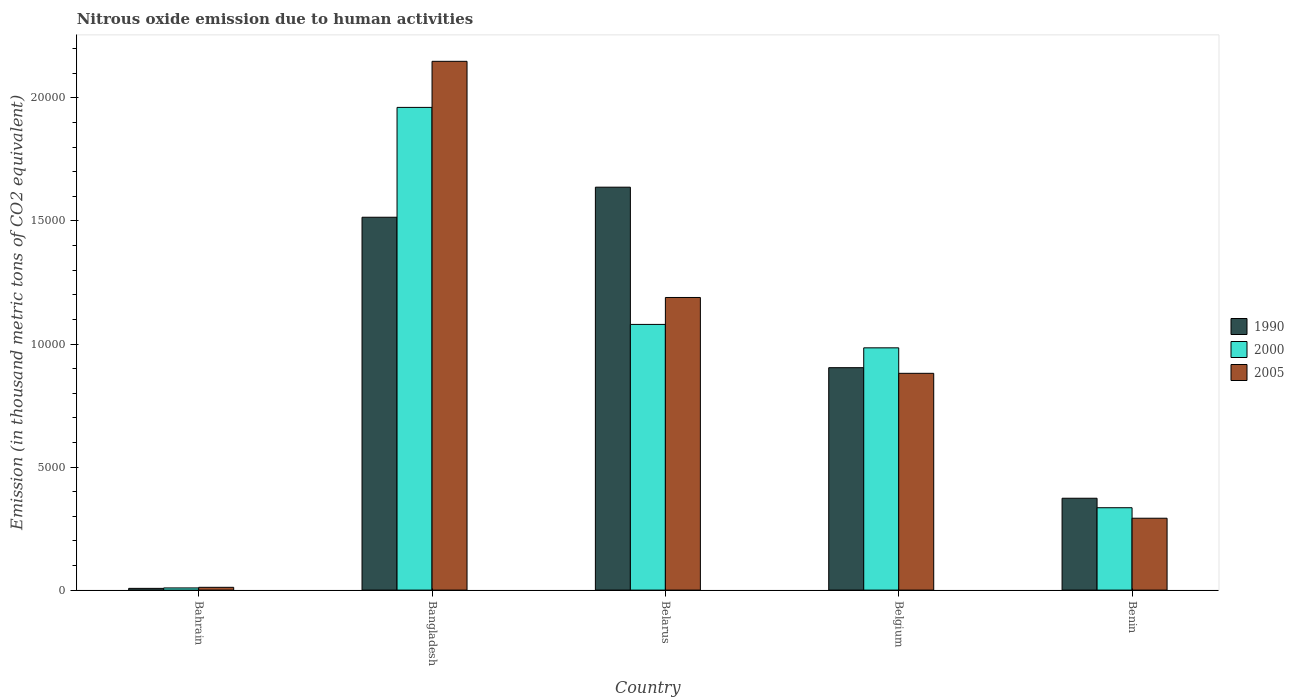How many different coloured bars are there?
Offer a very short reply. 3. Are the number of bars per tick equal to the number of legend labels?
Your response must be concise. Yes. Are the number of bars on each tick of the X-axis equal?
Your response must be concise. Yes. What is the label of the 1st group of bars from the left?
Provide a succinct answer. Bahrain. In how many cases, is the number of bars for a given country not equal to the number of legend labels?
Provide a succinct answer. 0. What is the amount of nitrous oxide emitted in 1990 in Belgium?
Your answer should be very brief. 9037.7. Across all countries, what is the maximum amount of nitrous oxide emitted in 1990?
Keep it short and to the point. 1.64e+04. Across all countries, what is the minimum amount of nitrous oxide emitted in 2005?
Make the answer very short. 112.9. In which country was the amount of nitrous oxide emitted in 1990 maximum?
Provide a succinct answer. Belarus. In which country was the amount of nitrous oxide emitted in 2005 minimum?
Offer a very short reply. Bahrain. What is the total amount of nitrous oxide emitted in 2005 in the graph?
Provide a succinct answer. 4.52e+04. What is the difference between the amount of nitrous oxide emitted in 2000 in Bangladesh and that in Belgium?
Offer a terse response. 9770.1. What is the difference between the amount of nitrous oxide emitted in 1990 in Bangladesh and the amount of nitrous oxide emitted in 2000 in Belarus?
Your answer should be very brief. 4354.7. What is the average amount of nitrous oxide emitted in 2000 per country?
Offer a terse response. 8737.92. What is the difference between the amount of nitrous oxide emitted of/in 1990 and amount of nitrous oxide emitted of/in 2005 in Benin?
Offer a terse response. 812.1. What is the ratio of the amount of nitrous oxide emitted in 2005 in Bangladesh to that in Belarus?
Make the answer very short. 1.81. Is the difference between the amount of nitrous oxide emitted in 1990 in Belgium and Benin greater than the difference between the amount of nitrous oxide emitted in 2005 in Belgium and Benin?
Your response must be concise. No. What is the difference between the highest and the second highest amount of nitrous oxide emitted in 1990?
Your answer should be compact. 7334.6. What is the difference between the highest and the lowest amount of nitrous oxide emitted in 2005?
Your answer should be very brief. 2.14e+04. In how many countries, is the amount of nitrous oxide emitted in 1990 greater than the average amount of nitrous oxide emitted in 1990 taken over all countries?
Your answer should be compact. 3. Is the sum of the amount of nitrous oxide emitted in 2005 in Bahrain and Belarus greater than the maximum amount of nitrous oxide emitted in 1990 across all countries?
Provide a short and direct response. No. What does the 1st bar from the left in Bangladesh represents?
Provide a succinct answer. 1990. What does the 1st bar from the right in Belgium represents?
Give a very brief answer. 2005. Is it the case that in every country, the sum of the amount of nitrous oxide emitted in 2000 and amount of nitrous oxide emitted in 2005 is greater than the amount of nitrous oxide emitted in 1990?
Offer a terse response. Yes. How many bars are there?
Offer a terse response. 15. How many countries are there in the graph?
Make the answer very short. 5. What is the difference between two consecutive major ticks on the Y-axis?
Give a very brief answer. 5000. Are the values on the major ticks of Y-axis written in scientific E-notation?
Offer a very short reply. No. Where does the legend appear in the graph?
Your answer should be compact. Center right. What is the title of the graph?
Make the answer very short. Nitrous oxide emission due to human activities. Does "2005" appear as one of the legend labels in the graph?
Your answer should be compact. Yes. What is the label or title of the X-axis?
Your response must be concise. Country. What is the label or title of the Y-axis?
Offer a very short reply. Emission (in thousand metric tons of CO2 equivalent). What is the Emission (in thousand metric tons of CO2 equivalent) of 1990 in Bahrain?
Your answer should be very brief. 70.2. What is the Emission (in thousand metric tons of CO2 equivalent) of 2000 in Bahrain?
Offer a terse response. 88.2. What is the Emission (in thousand metric tons of CO2 equivalent) of 2005 in Bahrain?
Provide a short and direct response. 112.9. What is the Emission (in thousand metric tons of CO2 equivalent) in 1990 in Bangladesh?
Provide a short and direct response. 1.52e+04. What is the Emission (in thousand metric tons of CO2 equivalent) of 2000 in Bangladesh?
Keep it short and to the point. 1.96e+04. What is the Emission (in thousand metric tons of CO2 equivalent) in 2005 in Bangladesh?
Make the answer very short. 2.15e+04. What is the Emission (in thousand metric tons of CO2 equivalent) of 1990 in Belarus?
Make the answer very short. 1.64e+04. What is the Emission (in thousand metric tons of CO2 equivalent) in 2000 in Belarus?
Offer a very short reply. 1.08e+04. What is the Emission (in thousand metric tons of CO2 equivalent) of 2005 in Belarus?
Your answer should be very brief. 1.19e+04. What is the Emission (in thousand metric tons of CO2 equivalent) of 1990 in Belgium?
Provide a succinct answer. 9037.7. What is the Emission (in thousand metric tons of CO2 equivalent) of 2000 in Belgium?
Ensure brevity in your answer.  9844.1. What is the Emission (in thousand metric tons of CO2 equivalent) in 2005 in Belgium?
Give a very brief answer. 8808.6. What is the Emission (in thousand metric tons of CO2 equivalent) of 1990 in Benin?
Provide a short and direct response. 3732.5. What is the Emission (in thousand metric tons of CO2 equivalent) of 2000 in Benin?
Offer a very short reply. 3347.2. What is the Emission (in thousand metric tons of CO2 equivalent) of 2005 in Benin?
Give a very brief answer. 2920.4. Across all countries, what is the maximum Emission (in thousand metric tons of CO2 equivalent) of 1990?
Ensure brevity in your answer.  1.64e+04. Across all countries, what is the maximum Emission (in thousand metric tons of CO2 equivalent) of 2000?
Your response must be concise. 1.96e+04. Across all countries, what is the maximum Emission (in thousand metric tons of CO2 equivalent) of 2005?
Offer a very short reply. 2.15e+04. Across all countries, what is the minimum Emission (in thousand metric tons of CO2 equivalent) in 1990?
Your response must be concise. 70.2. Across all countries, what is the minimum Emission (in thousand metric tons of CO2 equivalent) of 2000?
Ensure brevity in your answer.  88.2. Across all countries, what is the minimum Emission (in thousand metric tons of CO2 equivalent) in 2005?
Your answer should be very brief. 112.9. What is the total Emission (in thousand metric tons of CO2 equivalent) in 1990 in the graph?
Ensure brevity in your answer.  4.44e+04. What is the total Emission (in thousand metric tons of CO2 equivalent) of 2000 in the graph?
Offer a very short reply. 4.37e+04. What is the total Emission (in thousand metric tons of CO2 equivalent) in 2005 in the graph?
Your response must be concise. 4.52e+04. What is the difference between the Emission (in thousand metric tons of CO2 equivalent) of 1990 in Bahrain and that in Bangladesh?
Offer a very short reply. -1.51e+04. What is the difference between the Emission (in thousand metric tons of CO2 equivalent) in 2000 in Bahrain and that in Bangladesh?
Your response must be concise. -1.95e+04. What is the difference between the Emission (in thousand metric tons of CO2 equivalent) of 2005 in Bahrain and that in Bangladesh?
Offer a terse response. -2.14e+04. What is the difference between the Emission (in thousand metric tons of CO2 equivalent) of 1990 in Bahrain and that in Belarus?
Provide a short and direct response. -1.63e+04. What is the difference between the Emission (in thousand metric tons of CO2 equivalent) of 2000 in Bahrain and that in Belarus?
Make the answer very short. -1.07e+04. What is the difference between the Emission (in thousand metric tons of CO2 equivalent) in 2005 in Bahrain and that in Belarus?
Ensure brevity in your answer.  -1.18e+04. What is the difference between the Emission (in thousand metric tons of CO2 equivalent) of 1990 in Bahrain and that in Belgium?
Offer a terse response. -8967.5. What is the difference between the Emission (in thousand metric tons of CO2 equivalent) in 2000 in Bahrain and that in Belgium?
Your answer should be compact. -9755.9. What is the difference between the Emission (in thousand metric tons of CO2 equivalent) of 2005 in Bahrain and that in Belgium?
Make the answer very short. -8695.7. What is the difference between the Emission (in thousand metric tons of CO2 equivalent) of 1990 in Bahrain and that in Benin?
Offer a terse response. -3662.3. What is the difference between the Emission (in thousand metric tons of CO2 equivalent) of 2000 in Bahrain and that in Benin?
Keep it short and to the point. -3259. What is the difference between the Emission (in thousand metric tons of CO2 equivalent) in 2005 in Bahrain and that in Benin?
Make the answer very short. -2807.5. What is the difference between the Emission (in thousand metric tons of CO2 equivalent) in 1990 in Bangladesh and that in Belarus?
Offer a terse response. -1221.7. What is the difference between the Emission (in thousand metric tons of CO2 equivalent) in 2000 in Bangladesh and that in Belarus?
Your answer should be compact. 8818.3. What is the difference between the Emission (in thousand metric tons of CO2 equivalent) in 2005 in Bangladesh and that in Belarus?
Provide a short and direct response. 9596.5. What is the difference between the Emission (in thousand metric tons of CO2 equivalent) of 1990 in Bangladesh and that in Belgium?
Offer a terse response. 6112.9. What is the difference between the Emission (in thousand metric tons of CO2 equivalent) of 2000 in Bangladesh and that in Belgium?
Make the answer very short. 9770.1. What is the difference between the Emission (in thousand metric tons of CO2 equivalent) of 2005 in Bangladesh and that in Belgium?
Provide a short and direct response. 1.27e+04. What is the difference between the Emission (in thousand metric tons of CO2 equivalent) of 1990 in Bangladesh and that in Benin?
Provide a succinct answer. 1.14e+04. What is the difference between the Emission (in thousand metric tons of CO2 equivalent) in 2000 in Bangladesh and that in Benin?
Your response must be concise. 1.63e+04. What is the difference between the Emission (in thousand metric tons of CO2 equivalent) of 2005 in Bangladesh and that in Benin?
Keep it short and to the point. 1.86e+04. What is the difference between the Emission (in thousand metric tons of CO2 equivalent) in 1990 in Belarus and that in Belgium?
Keep it short and to the point. 7334.6. What is the difference between the Emission (in thousand metric tons of CO2 equivalent) of 2000 in Belarus and that in Belgium?
Your answer should be compact. 951.8. What is the difference between the Emission (in thousand metric tons of CO2 equivalent) of 2005 in Belarus and that in Belgium?
Offer a very short reply. 3081.6. What is the difference between the Emission (in thousand metric tons of CO2 equivalent) in 1990 in Belarus and that in Benin?
Keep it short and to the point. 1.26e+04. What is the difference between the Emission (in thousand metric tons of CO2 equivalent) in 2000 in Belarus and that in Benin?
Provide a succinct answer. 7448.7. What is the difference between the Emission (in thousand metric tons of CO2 equivalent) of 2005 in Belarus and that in Benin?
Give a very brief answer. 8969.8. What is the difference between the Emission (in thousand metric tons of CO2 equivalent) in 1990 in Belgium and that in Benin?
Keep it short and to the point. 5305.2. What is the difference between the Emission (in thousand metric tons of CO2 equivalent) of 2000 in Belgium and that in Benin?
Provide a succinct answer. 6496.9. What is the difference between the Emission (in thousand metric tons of CO2 equivalent) of 2005 in Belgium and that in Benin?
Provide a short and direct response. 5888.2. What is the difference between the Emission (in thousand metric tons of CO2 equivalent) in 1990 in Bahrain and the Emission (in thousand metric tons of CO2 equivalent) in 2000 in Bangladesh?
Keep it short and to the point. -1.95e+04. What is the difference between the Emission (in thousand metric tons of CO2 equivalent) in 1990 in Bahrain and the Emission (in thousand metric tons of CO2 equivalent) in 2005 in Bangladesh?
Offer a terse response. -2.14e+04. What is the difference between the Emission (in thousand metric tons of CO2 equivalent) in 2000 in Bahrain and the Emission (in thousand metric tons of CO2 equivalent) in 2005 in Bangladesh?
Your response must be concise. -2.14e+04. What is the difference between the Emission (in thousand metric tons of CO2 equivalent) in 1990 in Bahrain and the Emission (in thousand metric tons of CO2 equivalent) in 2000 in Belarus?
Your answer should be very brief. -1.07e+04. What is the difference between the Emission (in thousand metric tons of CO2 equivalent) of 1990 in Bahrain and the Emission (in thousand metric tons of CO2 equivalent) of 2005 in Belarus?
Offer a very short reply. -1.18e+04. What is the difference between the Emission (in thousand metric tons of CO2 equivalent) in 2000 in Bahrain and the Emission (in thousand metric tons of CO2 equivalent) in 2005 in Belarus?
Your response must be concise. -1.18e+04. What is the difference between the Emission (in thousand metric tons of CO2 equivalent) in 1990 in Bahrain and the Emission (in thousand metric tons of CO2 equivalent) in 2000 in Belgium?
Your answer should be very brief. -9773.9. What is the difference between the Emission (in thousand metric tons of CO2 equivalent) of 1990 in Bahrain and the Emission (in thousand metric tons of CO2 equivalent) of 2005 in Belgium?
Your answer should be very brief. -8738.4. What is the difference between the Emission (in thousand metric tons of CO2 equivalent) of 2000 in Bahrain and the Emission (in thousand metric tons of CO2 equivalent) of 2005 in Belgium?
Make the answer very short. -8720.4. What is the difference between the Emission (in thousand metric tons of CO2 equivalent) of 1990 in Bahrain and the Emission (in thousand metric tons of CO2 equivalent) of 2000 in Benin?
Your answer should be very brief. -3277. What is the difference between the Emission (in thousand metric tons of CO2 equivalent) in 1990 in Bahrain and the Emission (in thousand metric tons of CO2 equivalent) in 2005 in Benin?
Provide a short and direct response. -2850.2. What is the difference between the Emission (in thousand metric tons of CO2 equivalent) of 2000 in Bahrain and the Emission (in thousand metric tons of CO2 equivalent) of 2005 in Benin?
Provide a succinct answer. -2832.2. What is the difference between the Emission (in thousand metric tons of CO2 equivalent) in 1990 in Bangladesh and the Emission (in thousand metric tons of CO2 equivalent) in 2000 in Belarus?
Provide a succinct answer. 4354.7. What is the difference between the Emission (in thousand metric tons of CO2 equivalent) of 1990 in Bangladesh and the Emission (in thousand metric tons of CO2 equivalent) of 2005 in Belarus?
Offer a very short reply. 3260.4. What is the difference between the Emission (in thousand metric tons of CO2 equivalent) in 2000 in Bangladesh and the Emission (in thousand metric tons of CO2 equivalent) in 2005 in Belarus?
Ensure brevity in your answer.  7724. What is the difference between the Emission (in thousand metric tons of CO2 equivalent) in 1990 in Bangladesh and the Emission (in thousand metric tons of CO2 equivalent) in 2000 in Belgium?
Provide a short and direct response. 5306.5. What is the difference between the Emission (in thousand metric tons of CO2 equivalent) in 1990 in Bangladesh and the Emission (in thousand metric tons of CO2 equivalent) in 2005 in Belgium?
Keep it short and to the point. 6342. What is the difference between the Emission (in thousand metric tons of CO2 equivalent) in 2000 in Bangladesh and the Emission (in thousand metric tons of CO2 equivalent) in 2005 in Belgium?
Ensure brevity in your answer.  1.08e+04. What is the difference between the Emission (in thousand metric tons of CO2 equivalent) of 1990 in Bangladesh and the Emission (in thousand metric tons of CO2 equivalent) of 2000 in Benin?
Provide a short and direct response. 1.18e+04. What is the difference between the Emission (in thousand metric tons of CO2 equivalent) of 1990 in Bangladesh and the Emission (in thousand metric tons of CO2 equivalent) of 2005 in Benin?
Make the answer very short. 1.22e+04. What is the difference between the Emission (in thousand metric tons of CO2 equivalent) in 2000 in Bangladesh and the Emission (in thousand metric tons of CO2 equivalent) in 2005 in Benin?
Your response must be concise. 1.67e+04. What is the difference between the Emission (in thousand metric tons of CO2 equivalent) of 1990 in Belarus and the Emission (in thousand metric tons of CO2 equivalent) of 2000 in Belgium?
Provide a short and direct response. 6528.2. What is the difference between the Emission (in thousand metric tons of CO2 equivalent) of 1990 in Belarus and the Emission (in thousand metric tons of CO2 equivalent) of 2005 in Belgium?
Keep it short and to the point. 7563.7. What is the difference between the Emission (in thousand metric tons of CO2 equivalent) of 2000 in Belarus and the Emission (in thousand metric tons of CO2 equivalent) of 2005 in Belgium?
Give a very brief answer. 1987.3. What is the difference between the Emission (in thousand metric tons of CO2 equivalent) of 1990 in Belarus and the Emission (in thousand metric tons of CO2 equivalent) of 2000 in Benin?
Your answer should be very brief. 1.30e+04. What is the difference between the Emission (in thousand metric tons of CO2 equivalent) in 1990 in Belarus and the Emission (in thousand metric tons of CO2 equivalent) in 2005 in Benin?
Your answer should be compact. 1.35e+04. What is the difference between the Emission (in thousand metric tons of CO2 equivalent) in 2000 in Belarus and the Emission (in thousand metric tons of CO2 equivalent) in 2005 in Benin?
Make the answer very short. 7875.5. What is the difference between the Emission (in thousand metric tons of CO2 equivalent) of 1990 in Belgium and the Emission (in thousand metric tons of CO2 equivalent) of 2000 in Benin?
Keep it short and to the point. 5690.5. What is the difference between the Emission (in thousand metric tons of CO2 equivalent) of 1990 in Belgium and the Emission (in thousand metric tons of CO2 equivalent) of 2005 in Benin?
Offer a very short reply. 6117.3. What is the difference between the Emission (in thousand metric tons of CO2 equivalent) of 2000 in Belgium and the Emission (in thousand metric tons of CO2 equivalent) of 2005 in Benin?
Your response must be concise. 6923.7. What is the average Emission (in thousand metric tons of CO2 equivalent) of 1990 per country?
Offer a terse response. 8872.66. What is the average Emission (in thousand metric tons of CO2 equivalent) in 2000 per country?
Give a very brief answer. 8737.92. What is the average Emission (in thousand metric tons of CO2 equivalent) in 2005 per country?
Ensure brevity in your answer.  9043.76. What is the difference between the Emission (in thousand metric tons of CO2 equivalent) in 1990 and Emission (in thousand metric tons of CO2 equivalent) in 2005 in Bahrain?
Keep it short and to the point. -42.7. What is the difference between the Emission (in thousand metric tons of CO2 equivalent) in 2000 and Emission (in thousand metric tons of CO2 equivalent) in 2005 in Bahrain?
Make the answer very short. -24.7. What is the difference between the Emission (in thousand metric tons of CO2 equivalent) in 1990 and Emission (in thousand metric tons of CO2 equivalent) in 2000 in Bangladesh?
Provide a short and direct response. -4463.6. What is the difference between the Emission (in thousand metric tons of CO2 equivalent) of 1990 and Emission (in thousand metric tons of CO2 equivalent) of 2005 in Bangladesh?
Keep it short and to the point. -6336.1. What is the difference between the Emission (in thousand metric tons of CO2 equivalent) in 2000 and Emission (in thousand metric tons of CO2 equivalent) in 2005 in Bangladesh?
Offer a very short reply. -1872.5. What is the difference between the Emission (in thousand metric tons of CO2 equivalent) in 1990 and Emission (in thousand metric tons of CO2 equivalent) in 2000 in Belarus?
Your answer should be compact. 5576.4. What is the difference between the Emission (in thousand metric tons of CO2 equivalent) of 1990 and Emission (in thousand metric tons of CO2 equivalent) of 2005 in Belarus?
Provide a succinct answer. 4482.1. What is the difference between the Emission (in thousand metric tons of CO2 equivalent) of 2000 and Emission (in thousand metric tons of CO2 equivalent) of 2005 in Belarus?
Offer a very short reply. -1094.3. What is the difference between the Emission (in thousand metric tons of CO2 equivalent) in 1990 and Emission (in thousand metric tons of CO2 equivalent) in 2000 in Belgium?
Your answer should be compact. -806.4. What is the difference between the Emission (in thousand metric tons of CO2 equivalent) in 1990 and Emission (in thousand metric tons of CO2 equivalent) in 2005 in Belgium?
Provide a succinct answer. 229.1. What is the difference between the Emission (in thousand metric tons of CO2 equivalent) of 2000 and Emission (in thousand metric tons of CO2 equivalent) of 2005 in Belgium?
Your answer should be compact. 1035.5. What is the difference between the Emission (in thousand metric tons of CO2 equivalent) in 1990 and Emission (in thousand metric tons of CO2 equivalent) in 2000 in Benin?
Make the answer very short. 385.3. What is the difference between the Emission (in thousand metric tons of CO2 equivalent) of 1990 and Emission (in thousand metric tons of CO2 equivalent) of 2005 in Benin?
Ensure brevity in your answer.  812.1. What is the difference between the Emission (in thousand metric tons of CO2 equivalent) of 2000 and Emission (in thousand metric tons of CO2 equivalent) of 2005 in Benin?
Your answer should be very brief. 426.8. What is the ratio of the Emission (in thousand metric tons of CO2 equivalent) of 1990 in Bahrain to that in Bangladesh?
Give a very brief answer. 0. What is the ratio of the Emission (in thousand metric tons of CO2 equivalent) of 2000 in Bahrain to that in Bangladesh?
Make the answer very short. 0. What is the ratio of the Emission (in thousand metric tons of CO2 equivalent) in 2005 in Bahrain to that in Bangladesh?
Your response must be concise. 0.01. What is the ratio of the Emission (in thousand metric tons of CO2 equivalent) in 1990 in Bahrain to that in Belarus?
Your response must be concise. 0. What is the ratio of the Emission (in thousand metric tons of CO2 equivalent) in 2000 in Bahrain to that in Belarus?
Your answer should be very brief. 0.01. What is the ratio of the Emission (in thousand metric tons of CO2 equivalent) in 2005 in Bahrain to that in Belarus?
Provide a succinct answer. 0.01. What is the ratio of the Emission (in thousand metric tons of CO2 equivalent) in 1990 in Bahrain to that in Belgium?
Your answer should be compact. 0.01. What is the ratio of the Emission (in thousand metric tons of CO2 equivalent) in 2000 in Bahrain to that in Belgium?
Offer a terse response. 0.01. What is the ratio of the Emission (in thousand metric tons of CO2 equivalent) of 2005 in Bahrain to that in Belgium?
Offer a very short reply. 0.01. What is the ratio of the Emission (in thousand metric tons of CO2 equivalent) of 1990 in Bahrain to that in Benin?
Your response must be concise. 0.02. What is the ratio of the Emission (in thousand metric tons of CO2 equivalent) of 2000 in Bahrain to that in Benin?
Make the answer very short. 0.03. What is the ratio of the Emission (in thousand metric tons of CO2 equivalent) in 2005 in Bahrain to that in Benin?
Give a very brief answer. 0.04. What is the ratio of the Emission (in thousand metric tons of CO2 equivalent) in 1990 in Bangladesh to that in Belarus?
Provide a short and direct response. 0.93. What is the ratio of the Emission (in thousand metric tons of CO2 equivalent) of 2000 in Bangladesh to that in Belarus?
Keep it short and to the point. 1.82. What is the ratio of the Emission (in thousand metric tons of CO2 equivalent) of 2005 in Bangladesh to that in Belarus?
Your answer should be very brief. 1.81. What is the ratio of the Emission (in thousand metric tons of CO2 equivalent) of 1990 in Bangladesh to that in Belgium?
Your answer should be compact. 1.68. What is the ratio of the Emission (in thousand metric tons of CO2 equivalent) in 2000 in Bangladesh to that in Belgium?
Make the answer very short. 1.99. What is the ratio of the Emission (in thousand metric tons of CO2 equivalent) in 2005 in Bangladesh to that in Belgium?
Your response must be concise. 2.44. What is the ratio of the Emission (in thousand metric tons of CO2 equivalent) of 1990 in Bangladesh to that in Benin?
Keep it short and to the point. 4.06. What is the ratio of the Emission (in thousand metric tons of CO2 equivalent) of 2000 in Bangladesh to that in Benin?
Offer a very short reply. 5.86. What is the ratio of the Emission (in thousand metric tons of CO2 equivalent) of 2005 in Bangladesh to that in Benin?
Your answer should be very brief. 7.36. What is the ratio of the Emission (in thousand metric tons of CO2 equivalent) of 1990 in Belarus to that in Belgium?
Provide a short and direct response. 1.81. What is the ratio of the Emission (in thousand metric tons of CO2 equivalent) in 2000 in Belarus to that in Belgium?
Your response must be concise. 1.1. What is the ratio of the Emission (in thousand metric tons of CO2 equivalent) in 2005 in Belarus to that in Belgium?
Your answer should be compact. 1.35. What is the ratio of the Emission (in thousand metric tons of CO2 equivalent) of 1990 in Belarus to that in Benin?
Keep it short and to the point. 4.39. What is the ratio of the Emission (in thousand metric tons of CO2 equivalent) of 2000 in Belarus to that in Benin?
Offer a terse response. 3.23. What is the ratio of the Emission (in thousand metric tons of CO2 equivalent) of 2005 in Belarus to that in Benin?
Your answer should be very brief. 4.07. What is the ratio of the Emission (in thousand metric tons of CO2 equivalent) in 1990 in Belgium to that in Benin?
Make the answer very short. 2.42. What is the ratio of the Emission (in thousand metric tons of CO2 equivalent) in 2000 in Belgium to that in Benin?
Your response must be concise. 2.94. What is the ratio of the Emission (in thousand metric tons of CO2 equivalent) in 2005 in Belgium to that in Benin?
Provide a short and direct response. 3.02. What is the difference between the highest and the second highest Emission (in thousand metric tons of CO2 equivalent) of 1990?
Offer a terse response. 1221.7. What is the difference between the highest and the second highest Emission (in thousand metric tons of CO2 equivalent) of 2000?
Your answer should be very brief. 8818.3. What is the difference between the highest and the second highest Emission (in thousand metric tons of CO2 equivalent) of 2005?
Provide a short and direct response. 9596.5. What is the difference between the highest and the lowest Emission (in thousand metric tons of CO2 equivalent) of 1990?
Provide a succinct answer. 1.63e+04. What is the difference between the highest and the lowest Emission (in thousand metric tons of CO2 equivalent) of 2000?
Ensure brevity in your answer.  1.95e+04. What is the difference between the highest and the lowest Emission (in thousand metric tons of CO2 equivalent) of 2005?
Provide a short and direct response. 2.14e+04. 